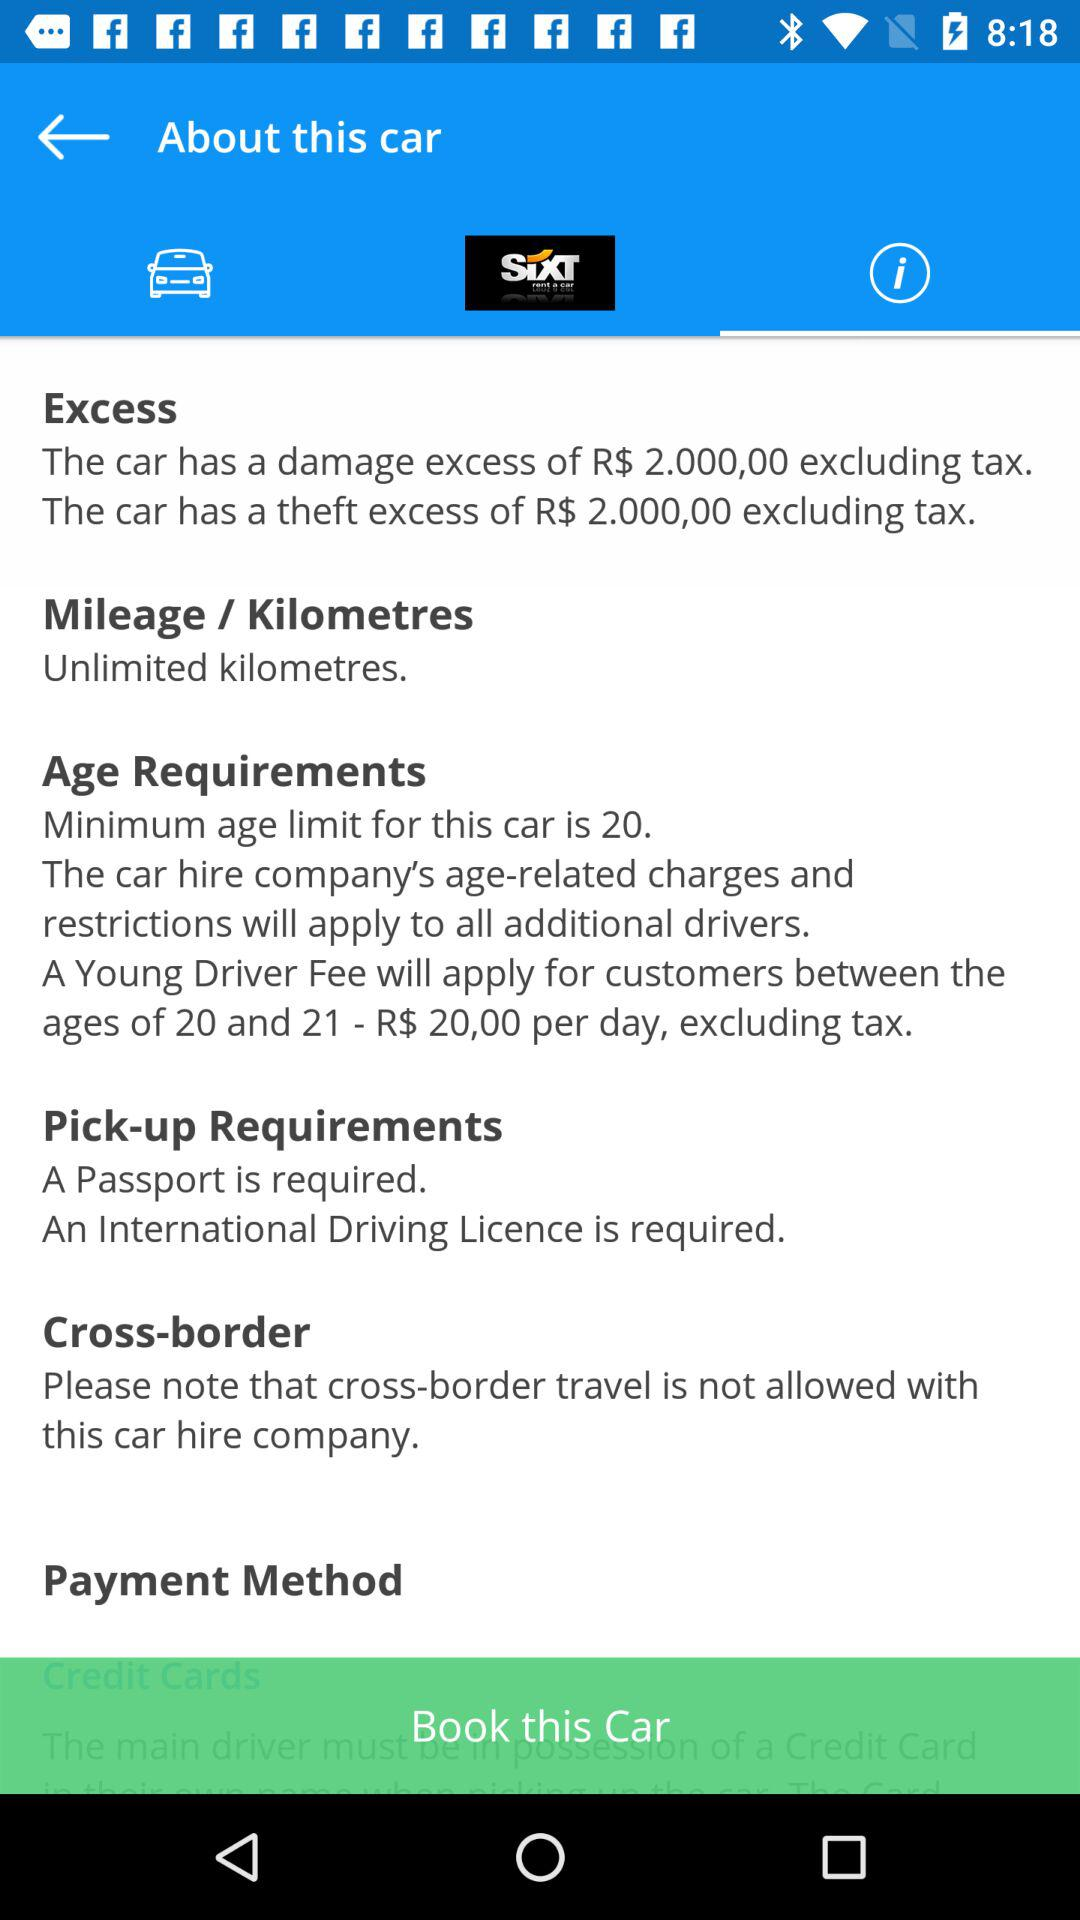How much is the damage excess for the car?
Answer the question using a single word or phrase. R$ 2.000,00 